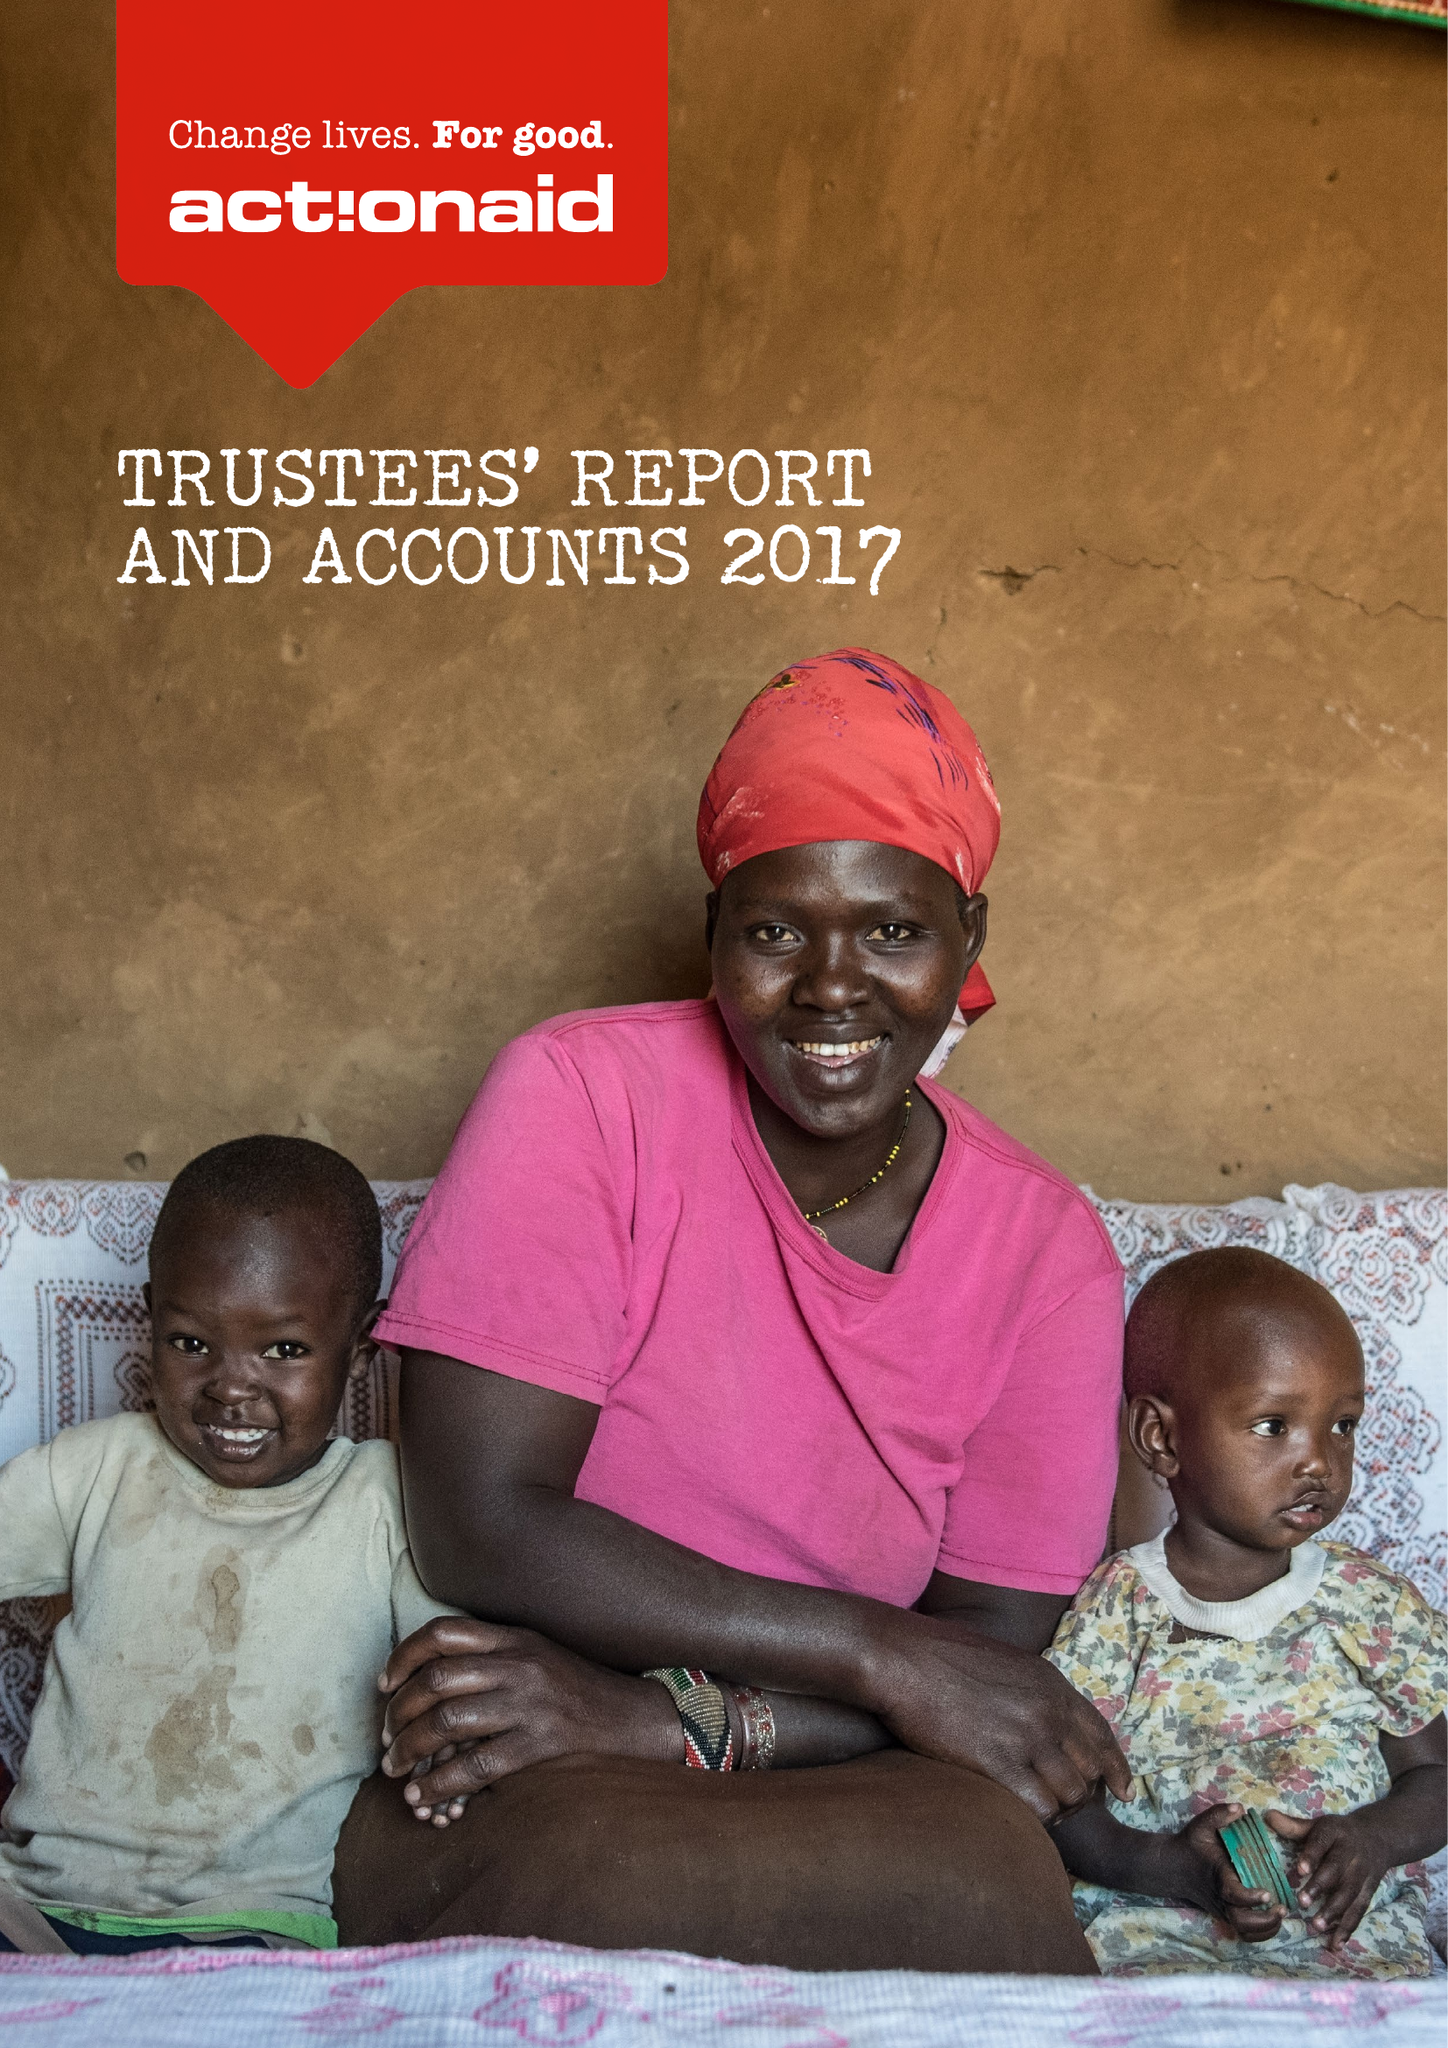What is the value for the income_annually_in_british_pounds?
Answer the question using a single word or phrase. 55037000.00 